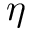Convert formula to latex. <formula><loc_0><loc_0><loc_500><loc_500>\boldsymbol \eta</formula> 